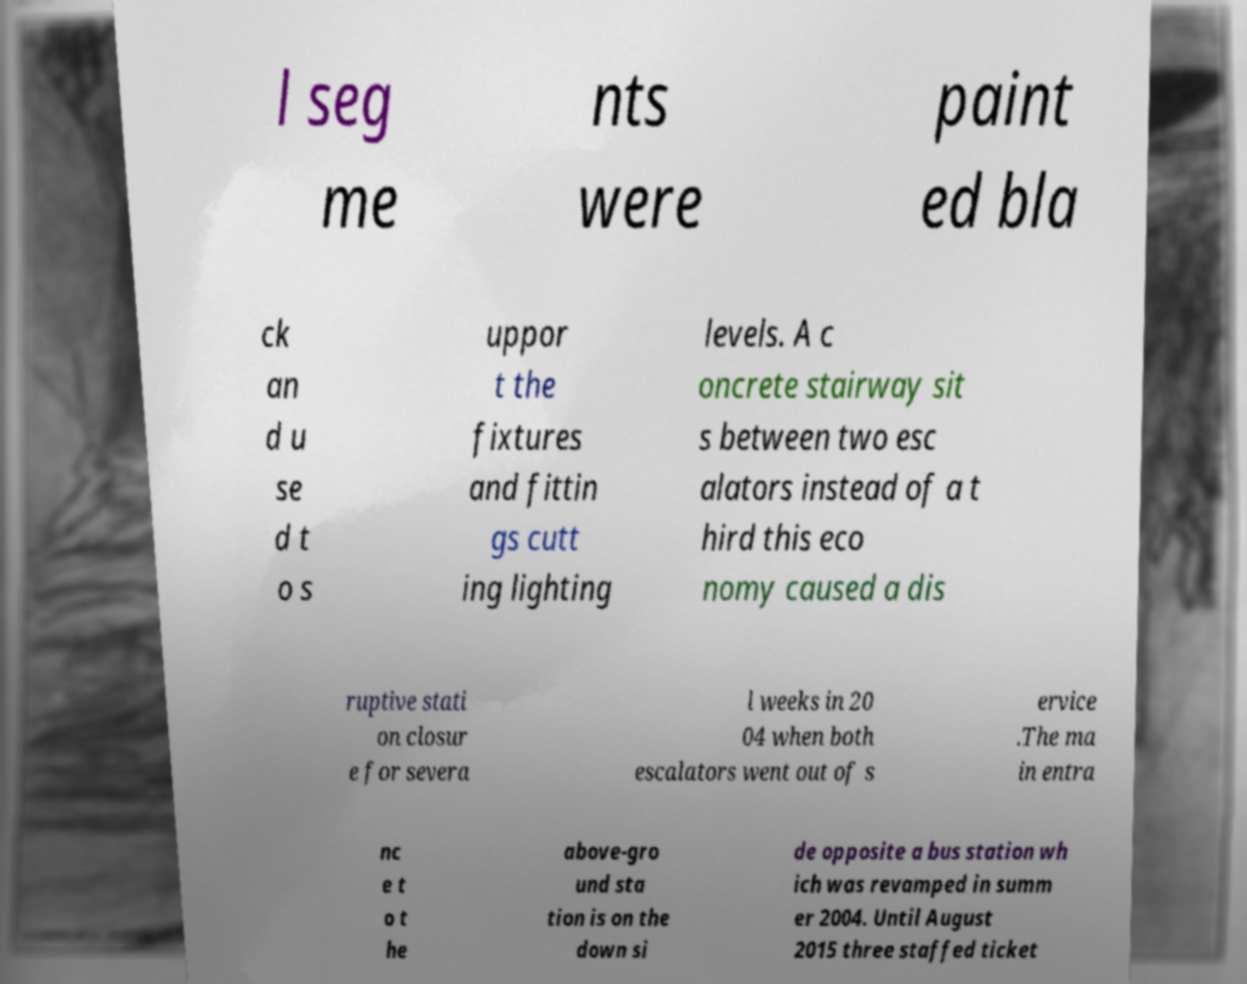Can you read and provide the text displayed in the image?This photo seems to have some interesting text. Can you extract and type it out for me? l seg me nts were paint ed bla ck an d u se d t o s uppor t the fixtures and fittin gs cutt ing lighting levels. A c oncrete stairway sit s between two esc alators instead of a t hird this eco nomy caused a dis ruptive stati on closur e for severa l weeks in 20 04 when both escalators went out of s ervice .The ma in entra nc e t o t he above-gro und sta tion is on the down si de opposite a bus station wh ich was revamped in summ er 2004. Until August 2015 three staffed ticket 